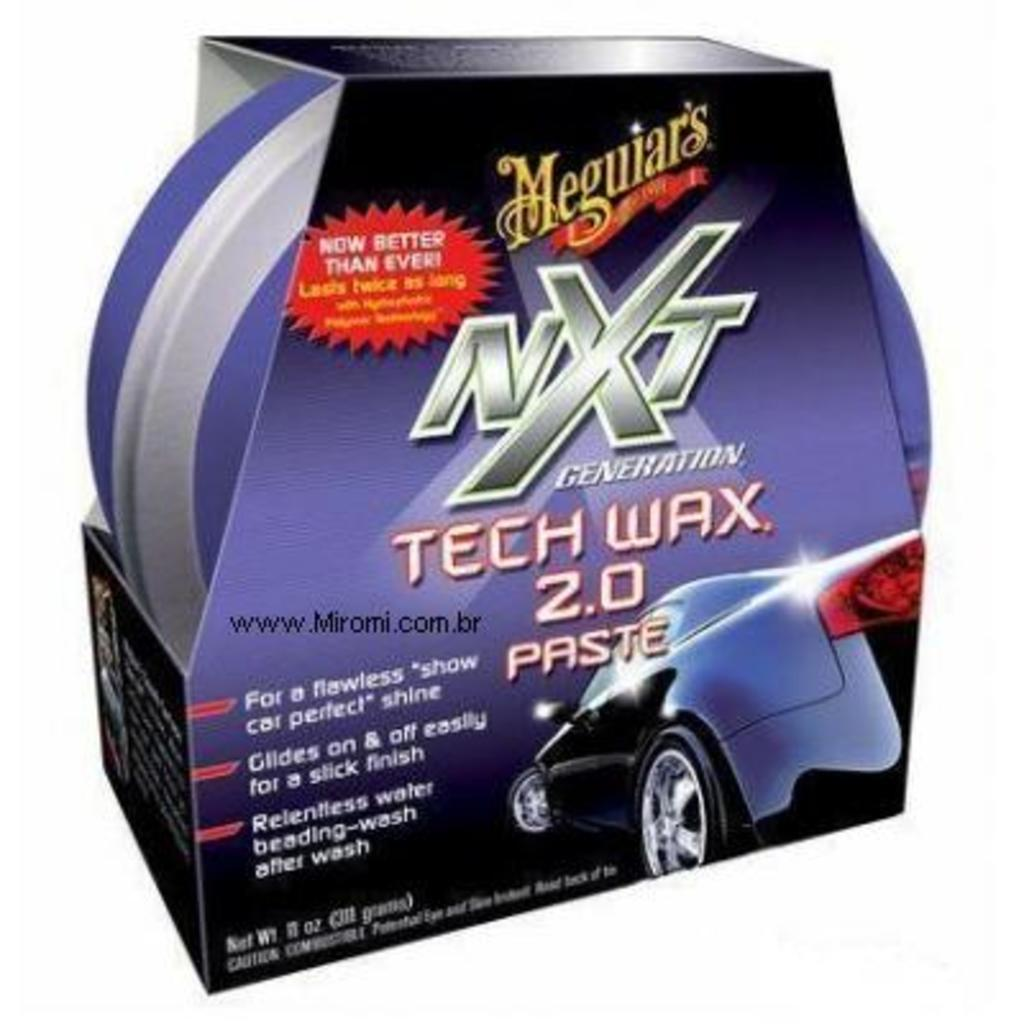What is present in the image that resembles a container? There is a box in the image. What is inside the box? The box contains an object. Can you describe any text on the box? Yes, there is text on the box, and it is related to a car. Is there any visual representation of a car on the box? Yes, there is an image of a car on the box. Is there a turkey roaming around in the image? No, there is no turkey present in the image. What is the range of the car depicted on the box? The range of the car cannot be determined from the image, as it only shows the box and not the car itself. 